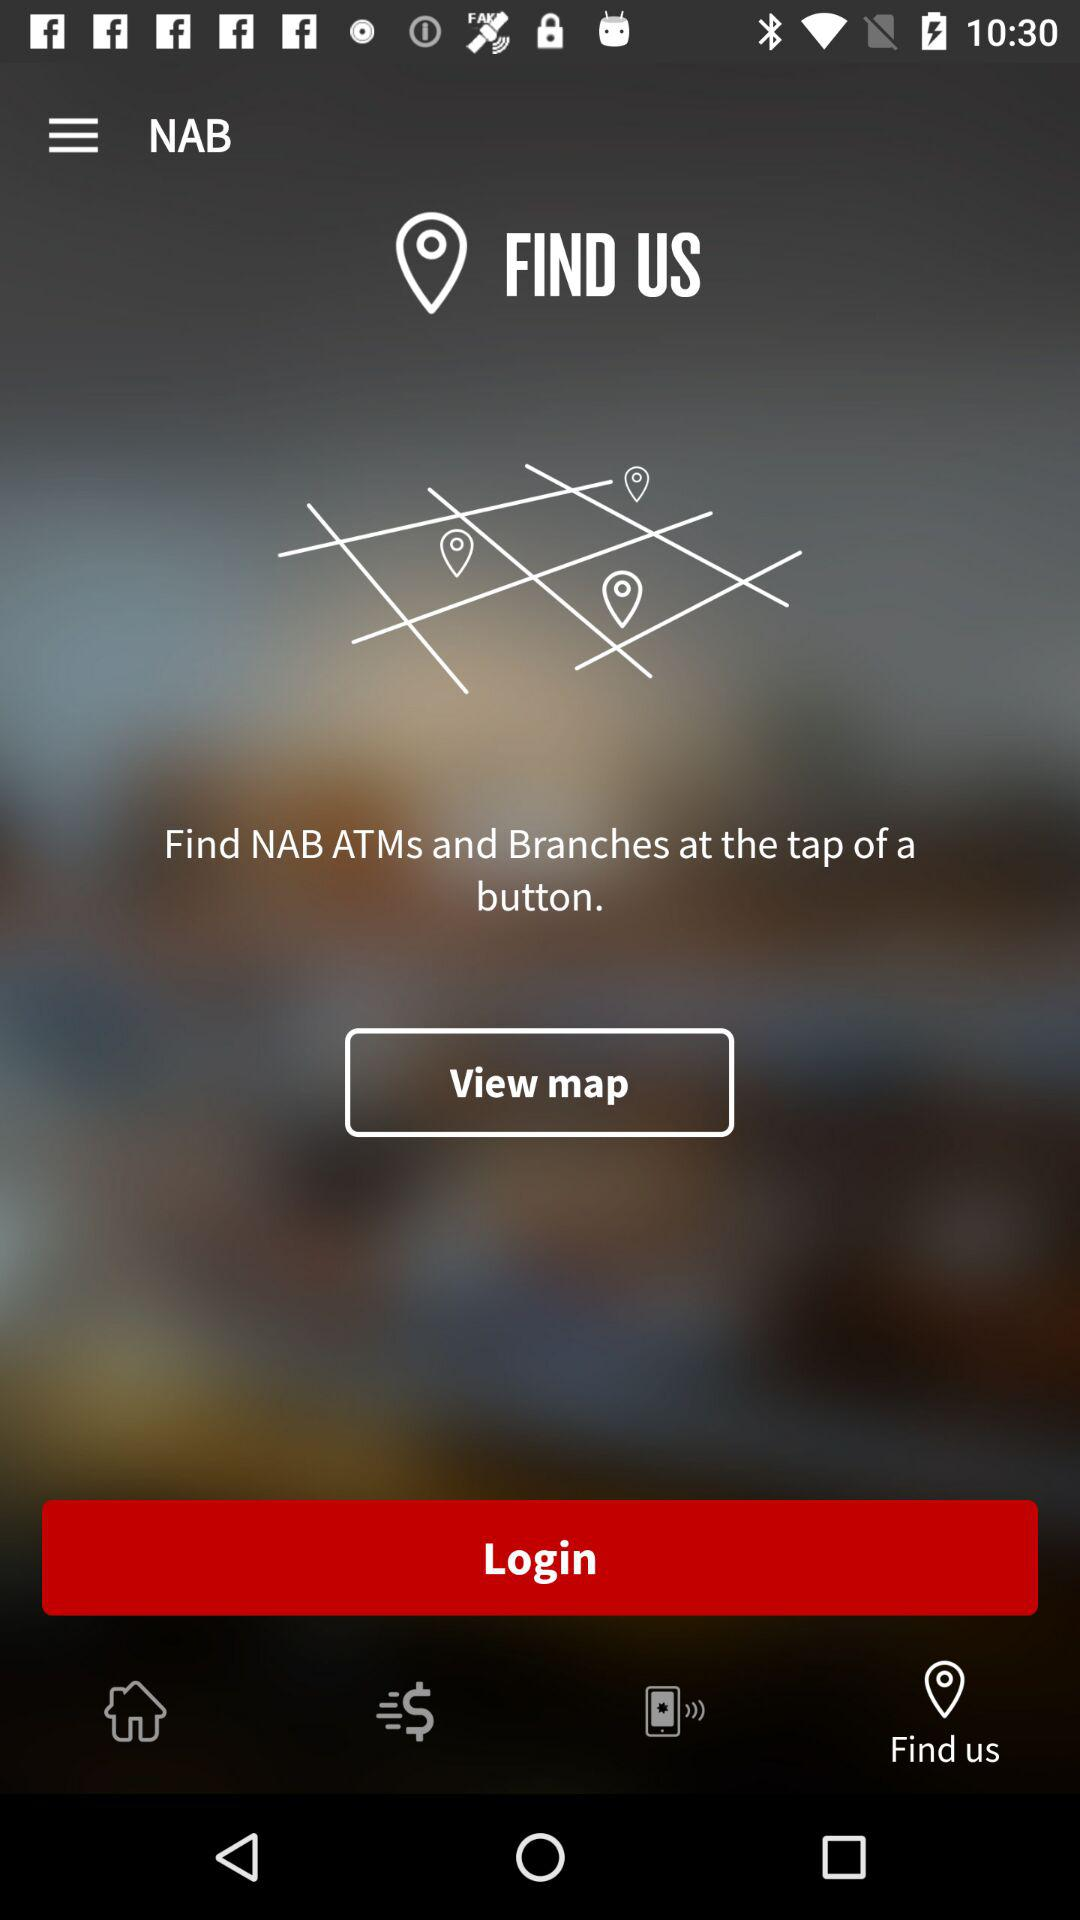What is the name of the application? The name of the application is "NAB". 